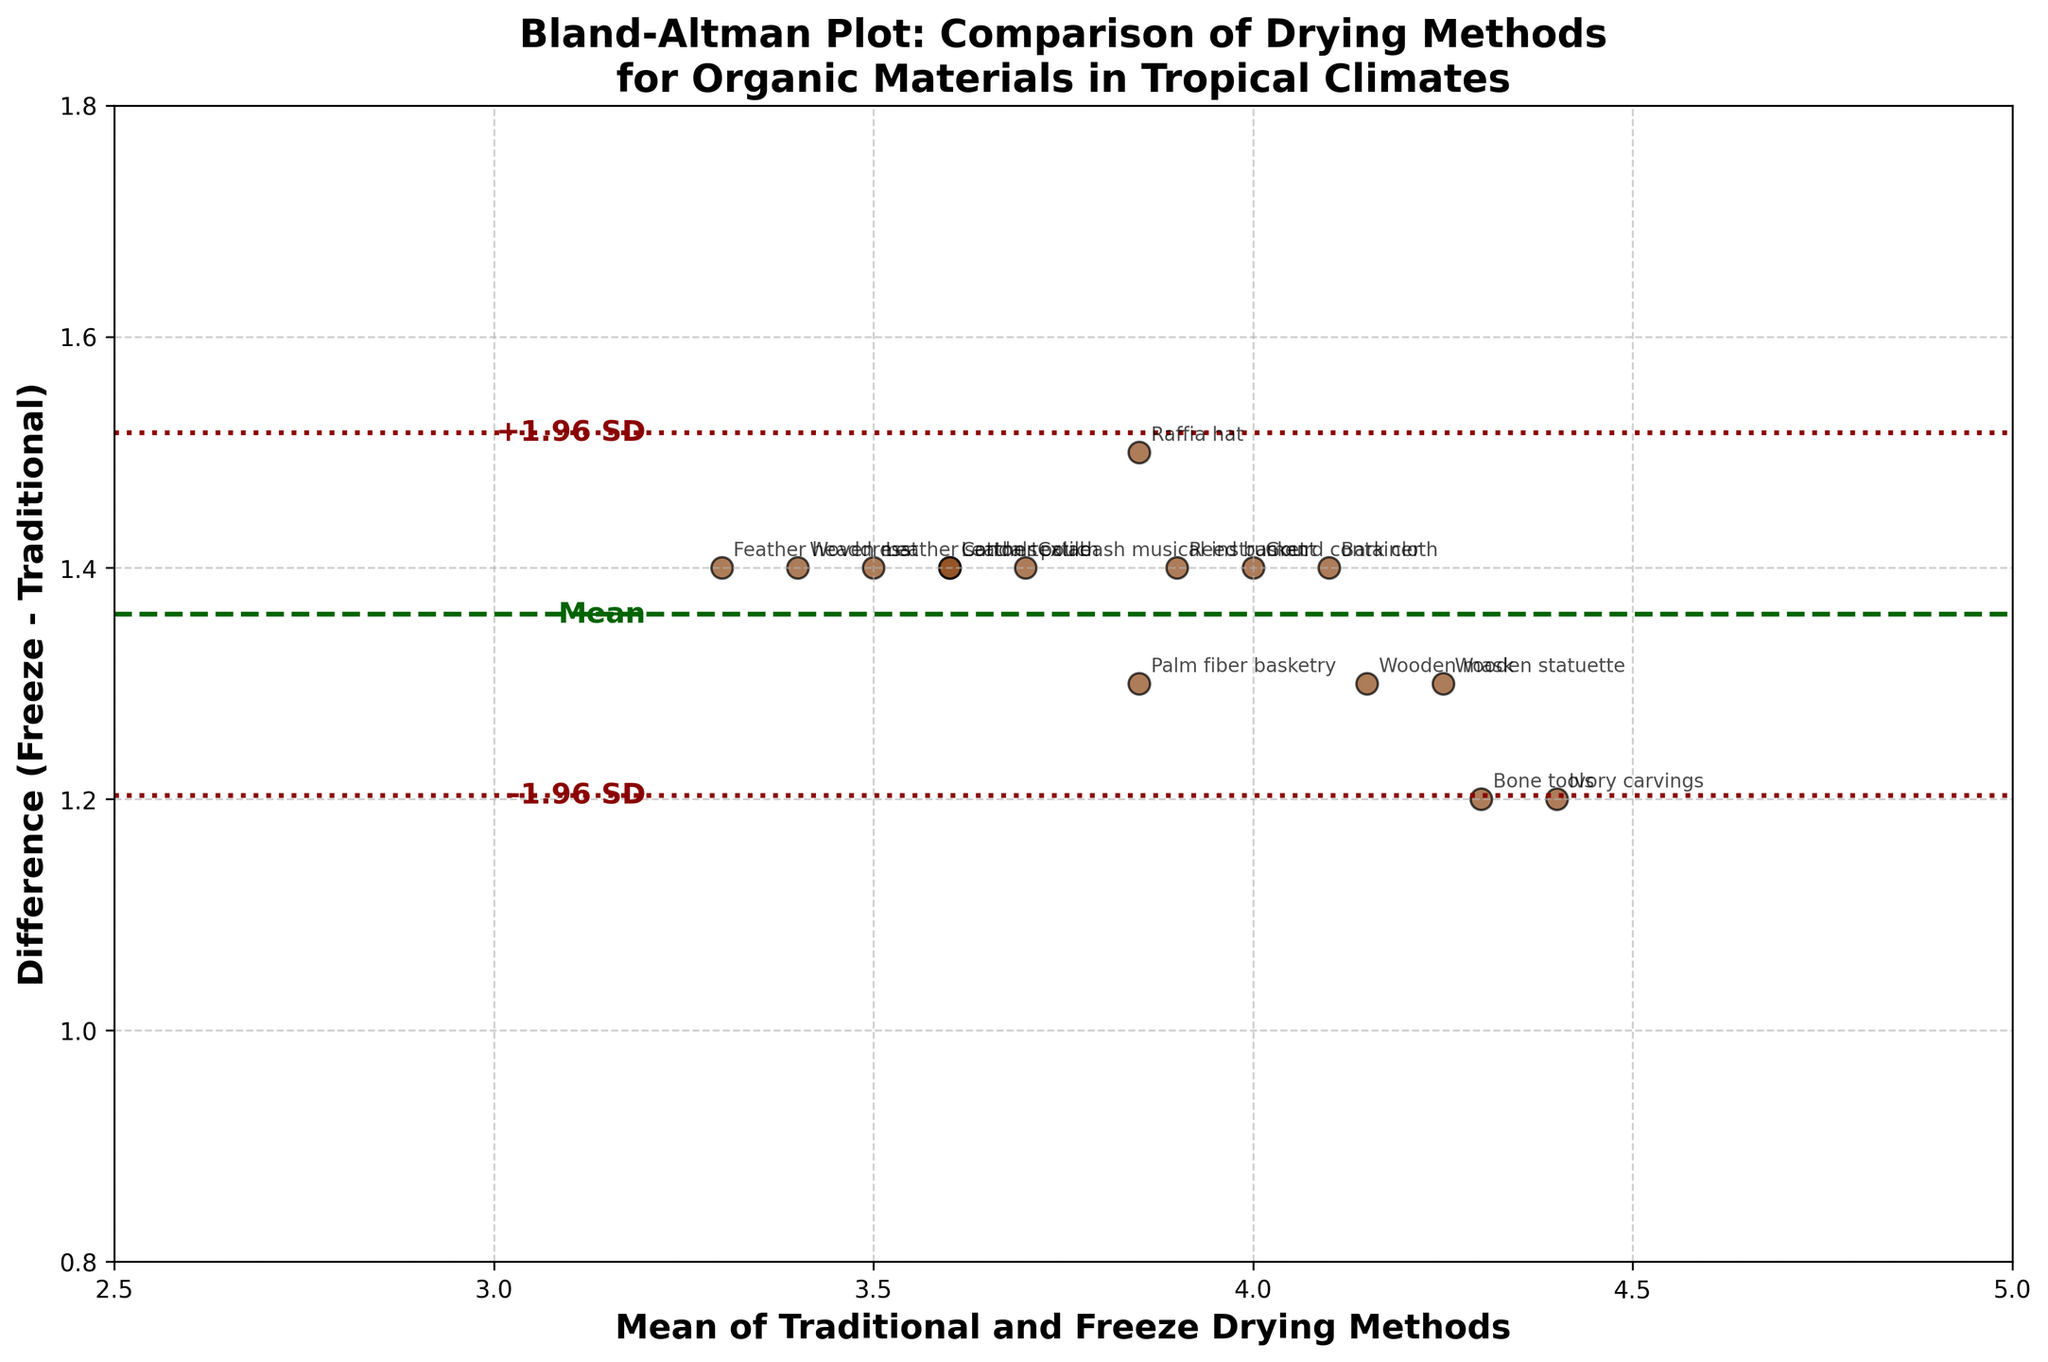What's the title of the plot? The title is prominently displayed at the top of the figure, making it straightforward to identify.
Answer: Bland-Altman Plot: Comparison of Drying Methods for Organic Materials in Tropical Climates What do the x-axis and y-axis represent? The x-axis represents the mean values of Traditional and Freeze Drying methods, and the y-axis represents the difference between Freeze and Traditional drying methods.
Answer: Mean of Traditional and Freeze Drying Methods / Difference (Freeze - Traditional) How many data points are plotted in the figure? Each method from the dataset is represented by a data point in the plot, and there are 15 entries.
Answer: 15 What color are the scatter points, and do they have any special style? The scatter points are colored brown and have black edges.
Answer: Brown with black edges What is the mean difference value, and how is it denoted on the plot? The mean difference is marked by a dashed green line. It is annotated with the text "Mean" on the plot.
Answer: 1.36 (mean of differences) What are the upper and lower limits of agreement, and how are they denoted? The limits of agreement are represented by dotted red lines. They are annotated with "-1.96 SD" and "+1.96 SD" on the plot.
Answer: Lower LoA: 1.26, Upper LoA: 1.46 Which method has the largest difference between Freeze Drying and Traditional Drying? The Raffia hat method shows the largest difference, as it has the highest y-value on the plot.
Answer: Raffia hat Which method has the smallest difference between Freeze Drying and Traditional Drying? Both Bone tools and Ivory carvings have the smallest difference, as they have the lowest y-values on the plot.
Answer: Bone tools and Ivory carvings What is the x-axis mean value for the Woven mat method? Locate the Woven mat method data point. The x-value represents the mean drying value.
Answer: 3.4 Would you say that Freeze Drying generally performs better than Traditional Drying based on the plotted differences? Since all plotted differences are positive, it indicates that Freeze Drying results in higher preservation values than Traditional Drying for all the methods.
Answer: Yes 